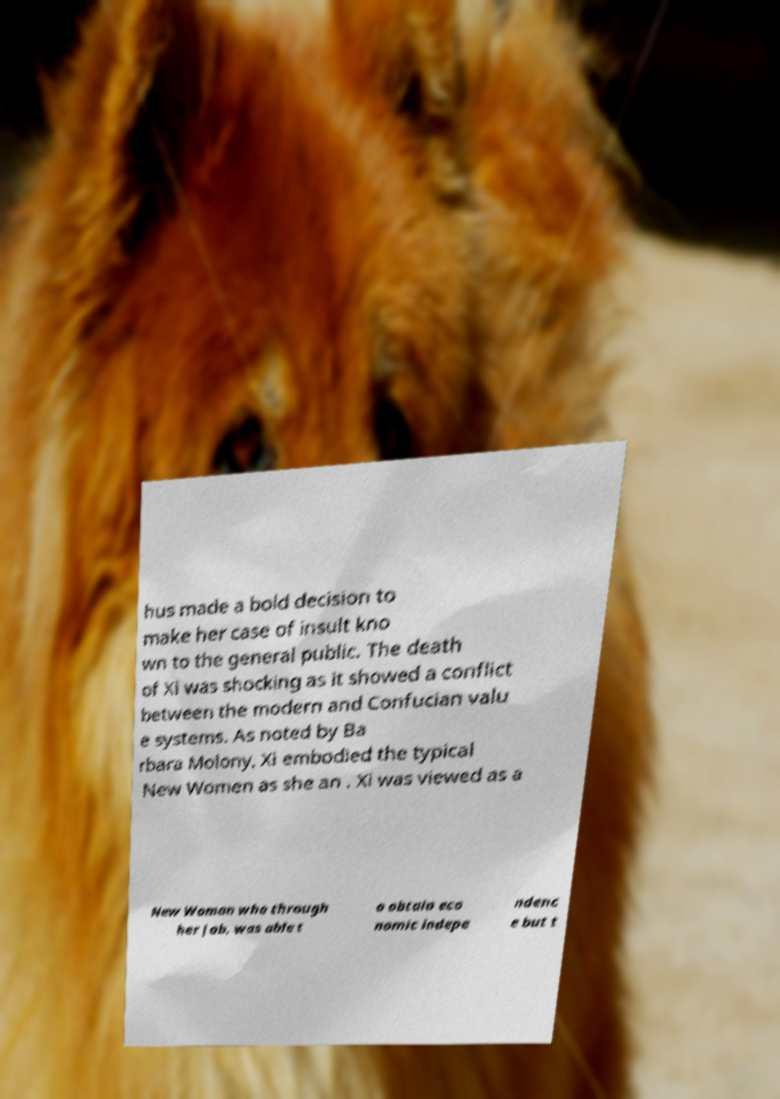Could you extract and type out the text from this image? hus made a bold decision to make her case of insult kno wn to the general public. The death of Xi was shocking as it showed a conflict between the modern and Confucian valu e systems. As noted by Ba rbara Molony, Xi embodied the typical New Women as she an . Xi was viewed as a New Woman who through her job, was able t o obtain eco nomic indepe ndenc e but t 